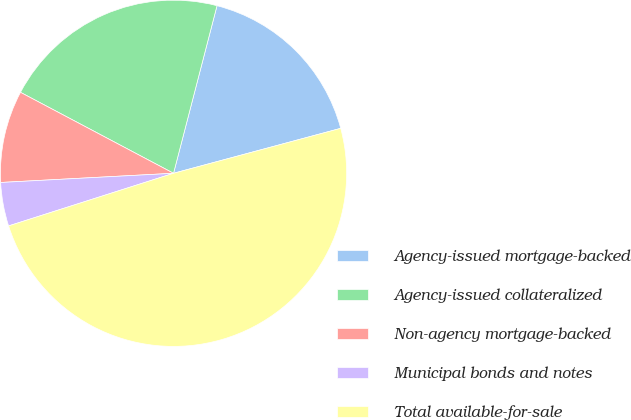<chart> <loc_0><loc_0><loc_500><loc_500><pie_chart><fcel>Agency-issued mortgage-backed<fcel>Agency-issued collateralized<fcel>Non-agency mortgage-backed<fcel>Municipal bonds and notes<fcel>Total available-for-sale<nl><fcel>16.78%<fcel>21.3%<fcel>8.59%<fcel>4.07%<fcel>49.27%<nl></chart> 